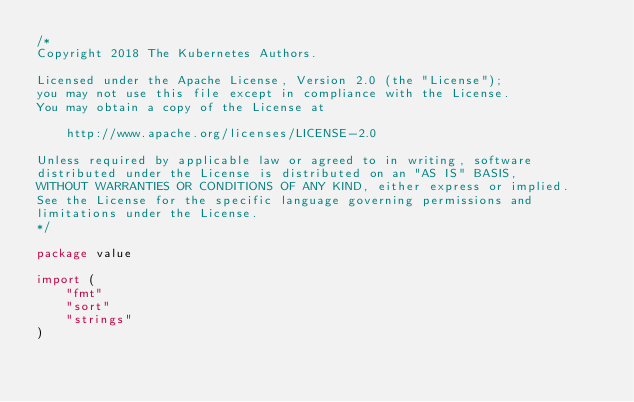<code> <loc_0><loc_0><loc_500><loc_500><_Go_>/*
Copyright 2018 The Kubernetes Authors.

Licensed under the Apache License, Version 2.0 (the "License");
you may not use this file except in compliance with the License.
You may obtain a copy of the License at

    http://www.apache.org/licenses/LICENSE-2.0

Unless required by applicable law or agreed to in writing, software
distributed under the License is distributed on an "AS IS" BASIS,
WITHOUT WARRANTIES OR CONDITIONS OF ANY KIND, either express or implied.
See the License for the specific language governing permissions and
limitations under the License.
*/

package value

import (
	"fmt"
	"sort"
	"strings"
)
</code> 